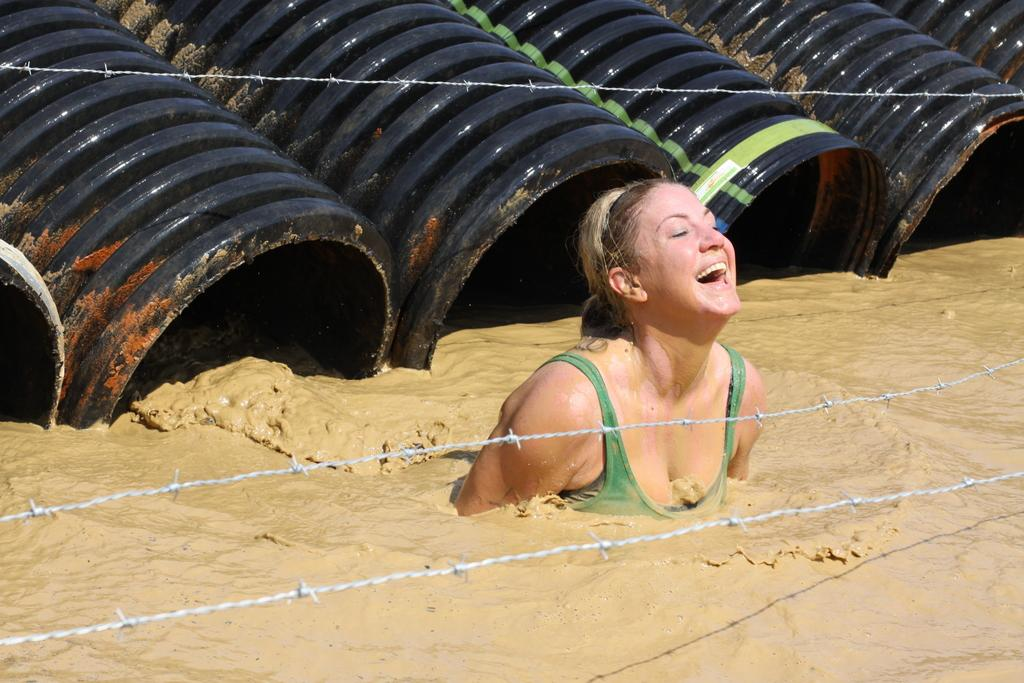What is the lady in the image doing? The lady is in the water in the image. What can be seen in the background of the image? There is fencing visible in the background of the image. What objects are at the top of the image? There are drums at the top of the image. What language is the lady speaking in the image? There is no indication of the lady speaking in the image, nor is there any information about the language she might be speaking. 